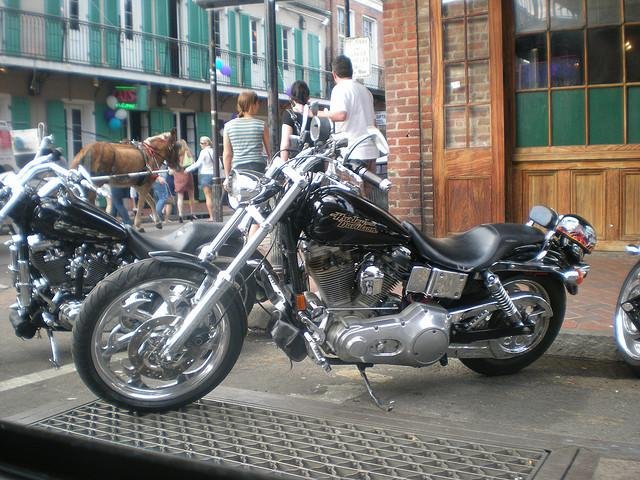What is this type of motorcycle known as? Please explain your reasoning. cruiser. Motorcycles that are cruisers are extra sleek. 